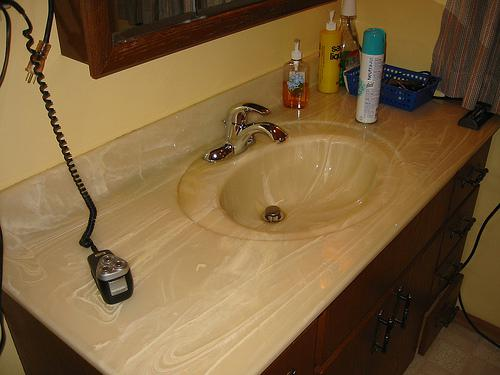Question: what room is this?
Choices:
A. Bedroom.
B. Bathroom.
C. Living room.
D. Play room.
Answer with the letter. Answer: B 